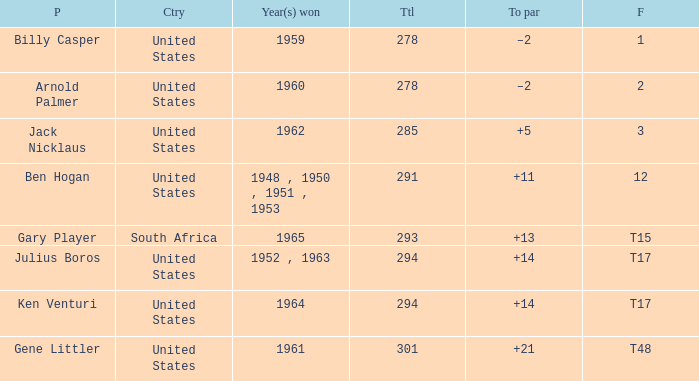What is Country, when Year(s) Won is "1962"? United States. 